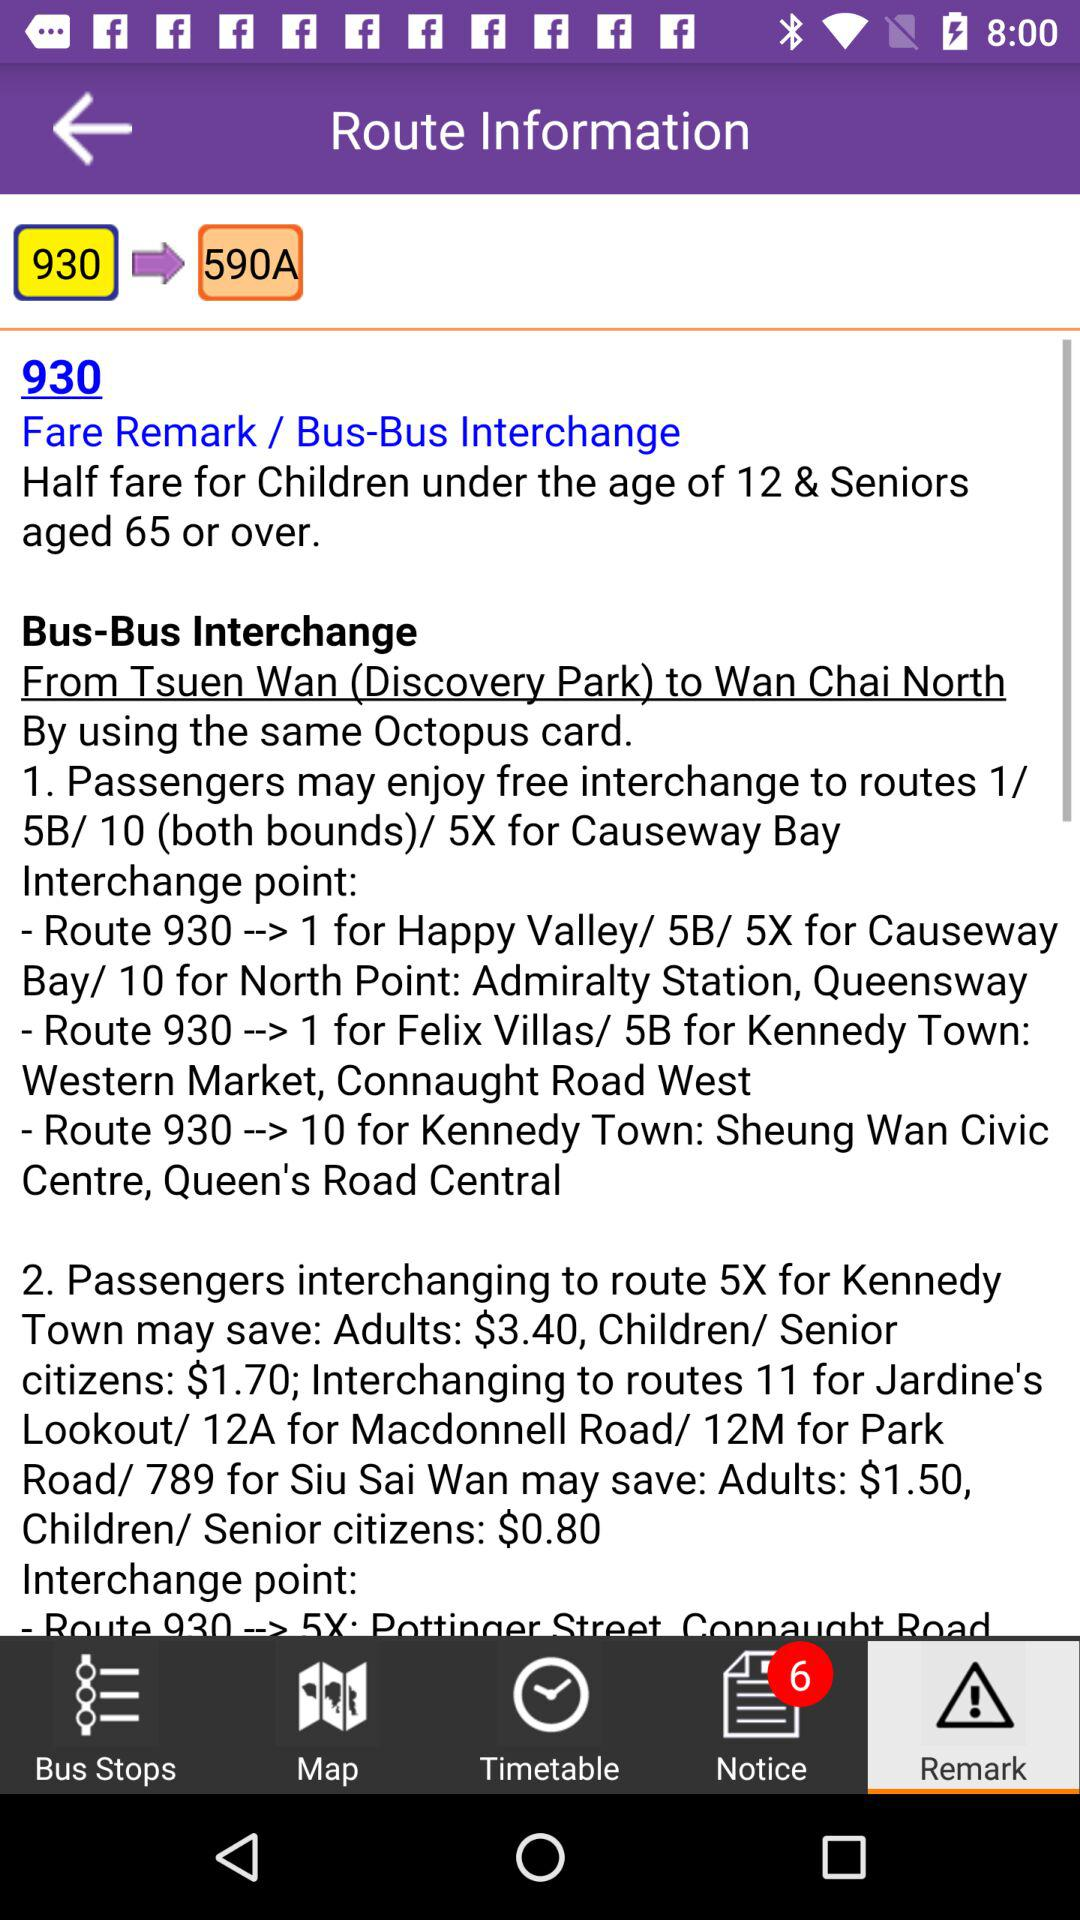Which tab is selected? The selected tab is "Remark". 